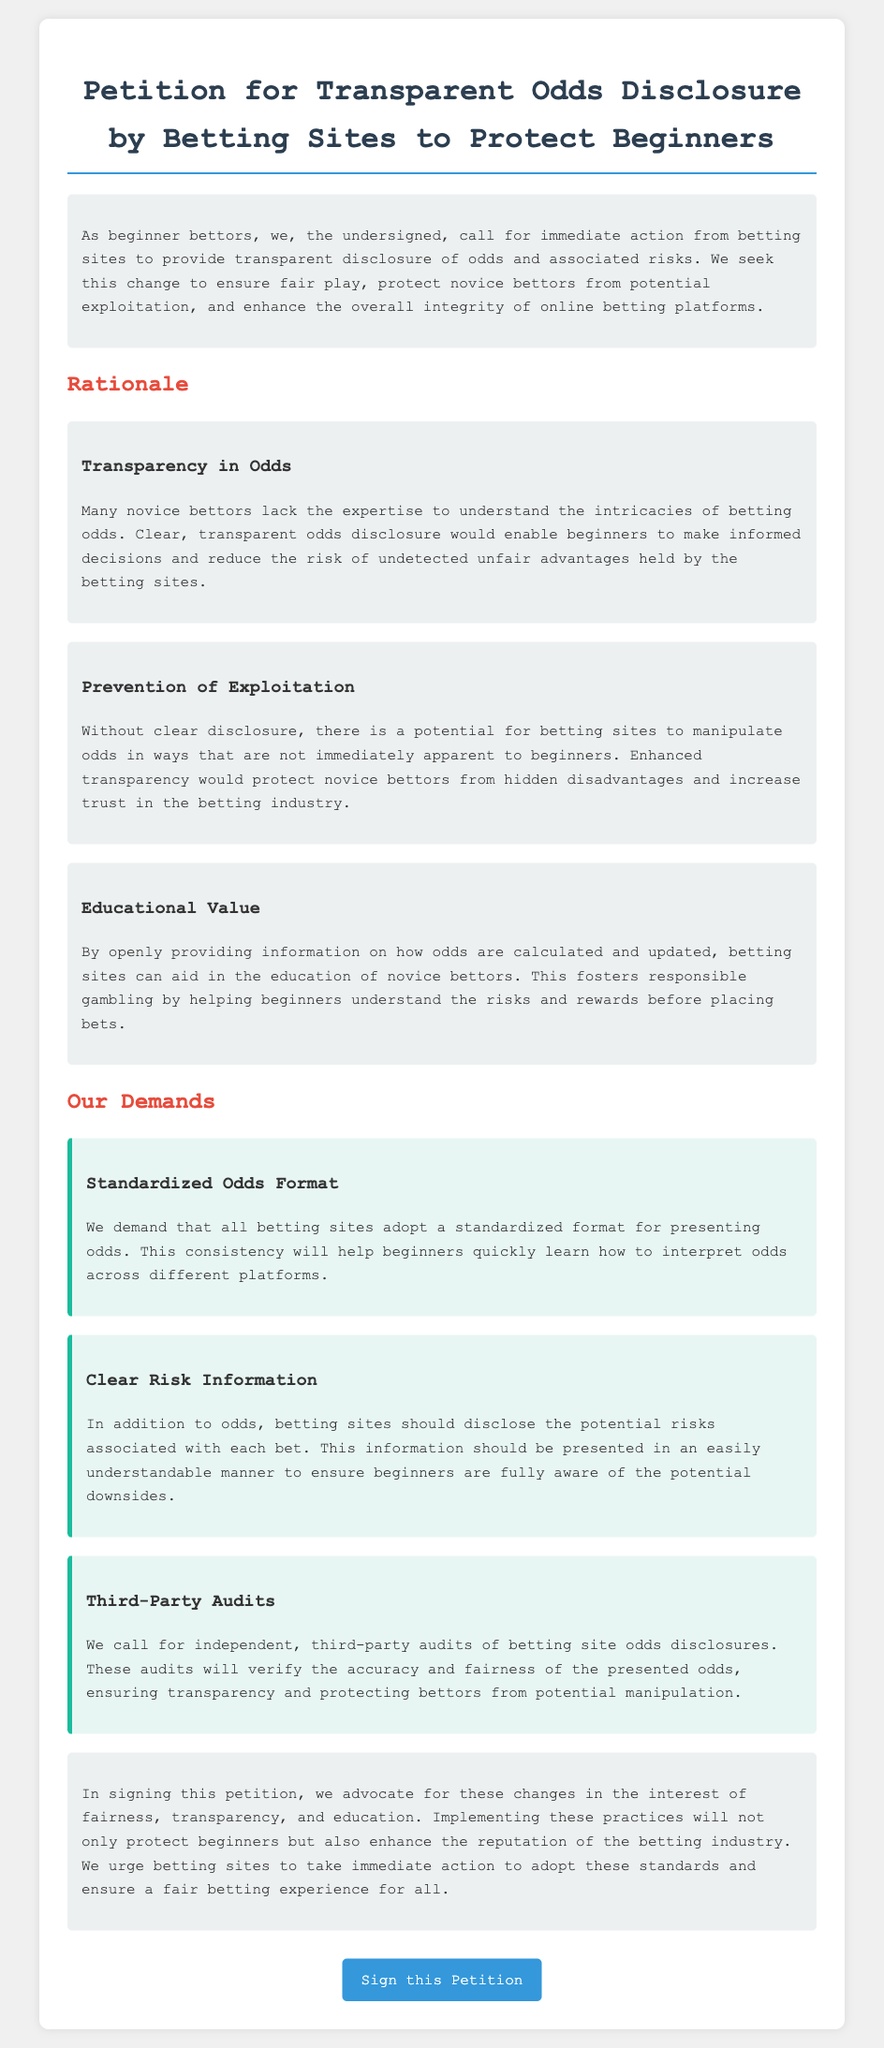What is the title of the petition? The title is stated prominently at the top of the document.
Answer: Petition for Transparent Odds Disclosure by Betting Sites to Protect Beginners Who is advocating for this petition? The petition begins by outlining the group pushing for the changes.
Answer: beginner bettors What is the main goal of the petition? The goal is described in the opening paragraph regarding transparency and protection.
Answer: transparent disclosure of odds What format do the petitioners demand for odds presentation? The document specifies a standardized format.
Answer: standardized odds format What educational benefit is mentioned for beginner bettors? The section discusses the advantage of providing clear odds calculations.
Answer: understanding the risks and rewards How many demands are made in total? The document lists specific demands under a section.
Answer: three What is the purpose of third-party audits mentioned in the petition? This purpose is detailed in the demand section.
Answer: verify the accuracy and fairness What section follows the rationale in the petition? The structure of the document outlines a progression in topics.
Answer: Our Demands What color is used for the heading "Rationale"? The color is specified in the style and can be found in the section titles.
Answer: red 